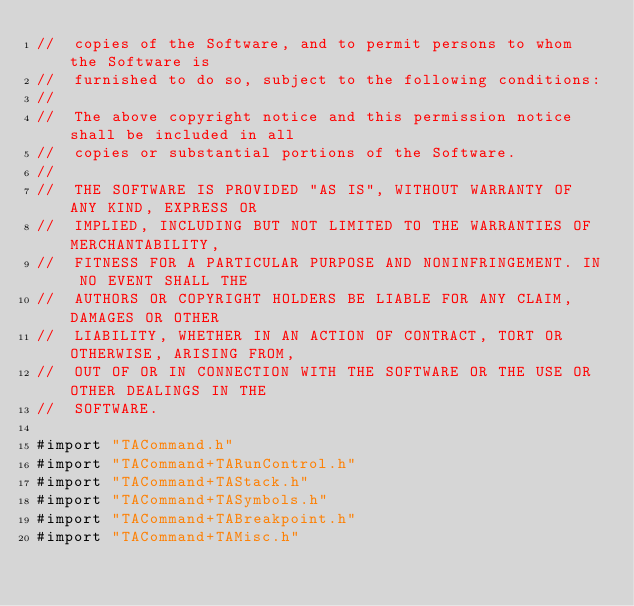<code> <loc_0><loc_0><loc_500><loc_500><_C_>//	copies of the Software, and to permit persons to whom the Software is
//	furnished to do so, subject to the following conditions:
//
//	The above copyright notice and this permission notice shall be included in all
//	copies or substantial portions of the Software.
//
//	THE SOFTWARE IS PROVIDED "AS IS", WITHOUT WARRANTY OF ANY KIND, EXPRESS OR
//	IMPLIED, INCLUDING BUT NOT LIMITED TO THE WARRANTIES OF MERCHANTABILITY,
//	FITNESS FOR A PARTICULAR PURPOSE AND NONINFRINGEMENT. IN NO EVENT SHALL THE
//	AUTHORS OR COPYRIGHT HOLDERS BE LIABLE FOR ANY CLAIM, DAMAGES OR OTHER
//	LIABILITY, WHETHER IN AN ACTION OF CONTRACT, TORT OR OTHERWISE, ARISING FROM,
//	OUT OF OR IN CONNECTION WITH THE SOFTWARE OR THE USE OR OTHER DEALINGS IN THE
//	SOFTWARE.

#import "TACommand.h"
#import "TACommand+TARunControl.h"
#import "TACommand+TAStack.h"
#import "TACommand+TASymbols.h"
#import "TACommand+TABreakpoint.h"
#import "TACommand+TAMisc.h"
</code> 